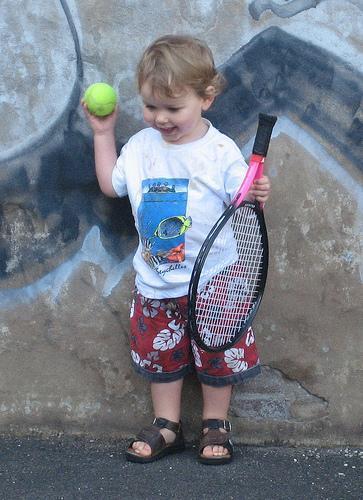How many people are in the picture?
Give a very brief answer. 1. How many colors are on the shorts?
Give a very brief answer. 4. 